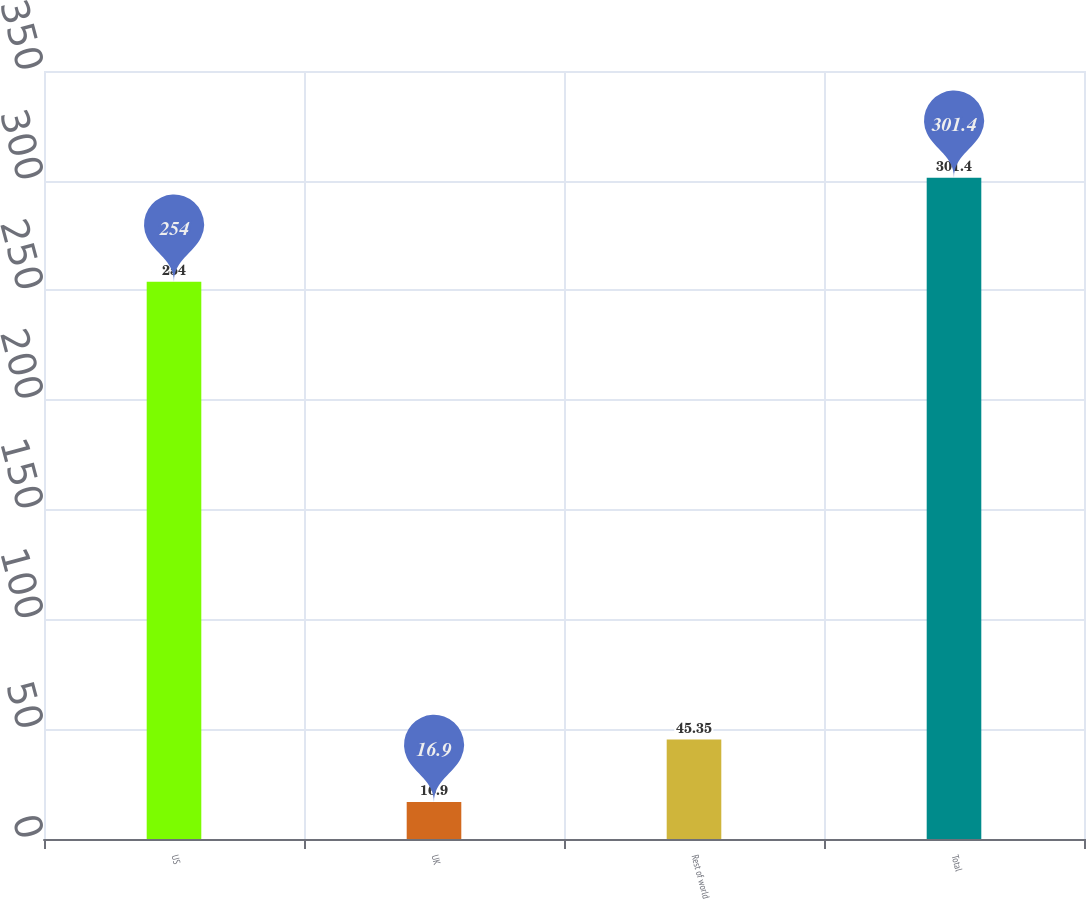Convert chart. <chart><loc_0><loc_0><loc_500><loc_500><bar_chart><fcel>US<fcel>UK<fcel>Rest of world<fcel>Total<nl><fcel>254<fcel>16.9<fcel>45.35<fcel>301.4<nl></chart> 